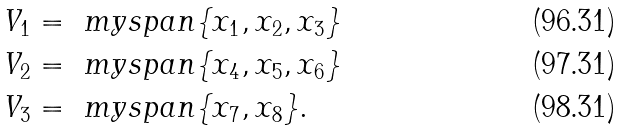<formula> <loc_0><loc_0><loc_500><loc_500>V _ { 1 } & = \ m y s p a n \{ x _ { 1 } , x _ { 2 } , x _ { 3 } \} \\ V _ { 2 } & = \ m y s p a n \{ x _ { 4 } , x _ { 5 } , x _ { 6 } \} \\ V _ { 3 } & = \ m y s p a n \{ x _ { 7 } , x _ { 8 } \} .</formula> 